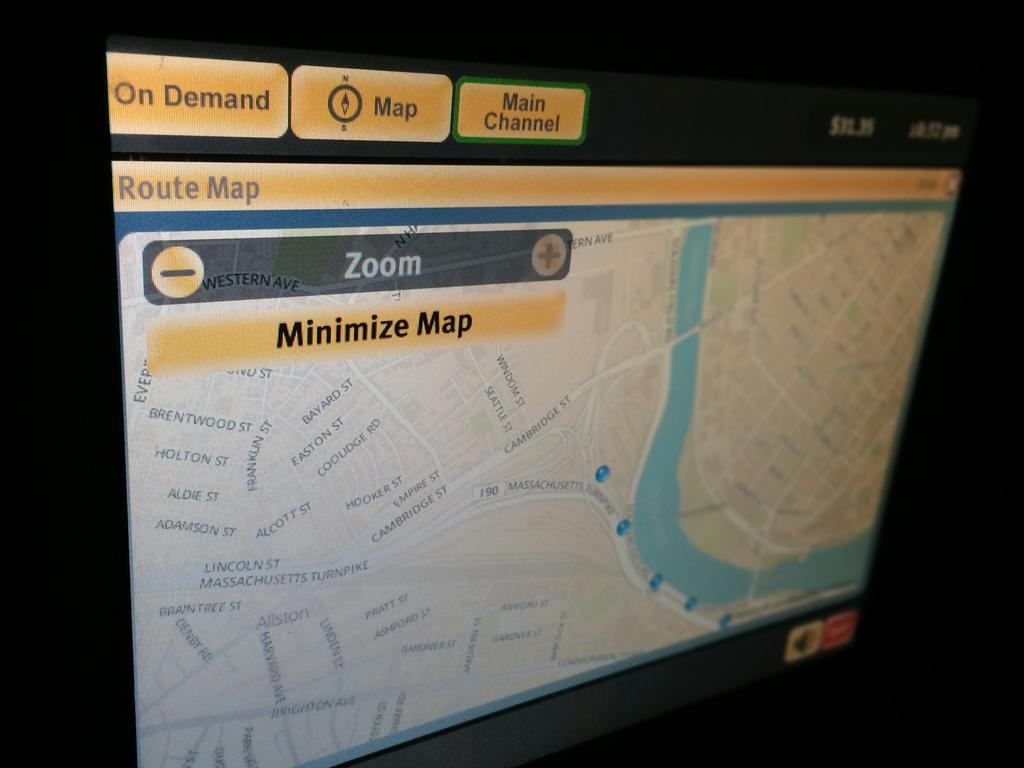<image>
Create a compact narrative representing the image presented. A boston area map on a computer allowing the user to zoom in and out. 